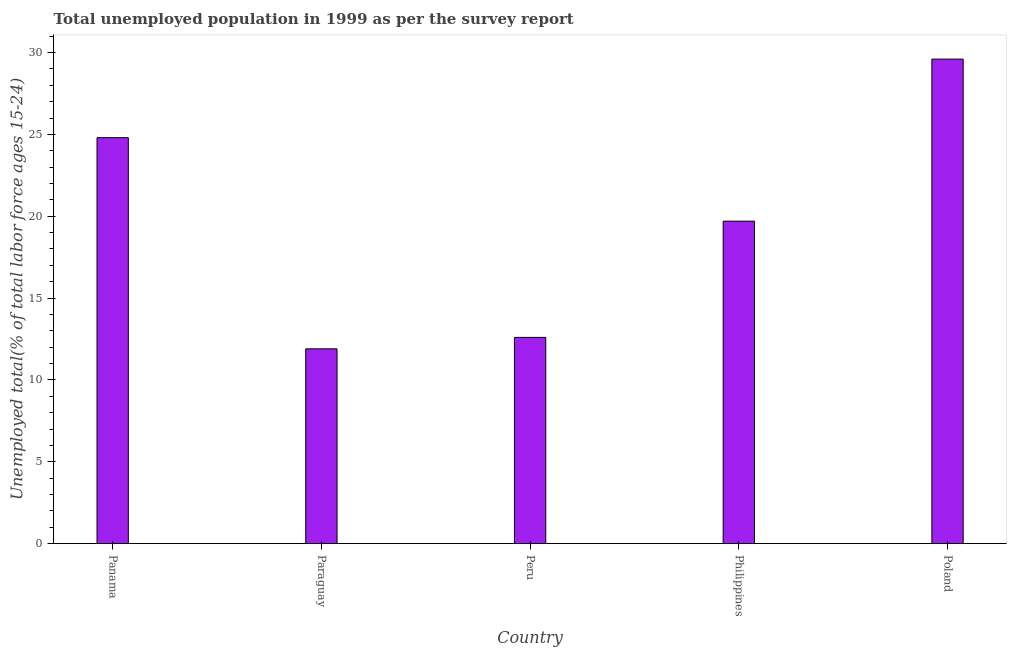What is the title of the graph?
Your answer should be compact. Total unemployed population in 1999 as per the survey report. What is the label or title of the Y-axis?
Your answer should be compact. Unemployed total(% of total labor force ages 15-24). What is the unemployed youth in Panama?
Your response must be concise. 24.8. Across all countries, what is the maximum unemployed youth?
Provide a short and direct response. 29.6. Across all countries, what is the minimum unemployed youth?
Your answer should be very brief. 11.9. In which country was the unemployed youth maximum?
Ensure brevity in your answer.  Poland. In which country was the unemployed youth minimum?
Your answer should be compact. Paraguay. What is the sum of the unemployed youth?
Ensure brevity in your answer.  98.6. What is the average unemployed youth per country?
Offer a terse response. 19.72. What is the median unemployed youth?
Provide a short and direct response. 19.7. What is the ratio of the unemployed youth in Peru to that in Poland?
Offer a terse response. 0.43. What is the difference between the highest and the second highest unemployed youth?
Offer a very short reply. 4.8. What is the difference between the highest and the lowest unemployed youth?
Your answer should be compact. 17.7. In how many countries, is the unemployed youth greater than the average unemployed youth taken over all countries?
Keep it short and to the point. 2. How many bars are there?
Keep it short and to the point. 5. Are all the bars in the graph horizontal?
Your answer should be compact. No. How many countries are there in the graph?
Offer a very short reply. 5. Are the values on the major ticks of Y-axis written in scientific E-notation?
Your response must be concise. No. What is the Unemployed total(% of total labor force ages 15-24) in Panama?
Give a very brief answer. 24.8. What is the Unemployed total(% of total labor force ages 15-24) in Paraguay?
Provide a succinct answer. 11.9. What is the Unemployed total(% of total labor force ages 15-24) of Peru?
Ensure brevity in your answer.  12.6. What is the Unemployed total(% of total labor force ages 15-24) in Philippines?
Your answer should be very brief. 19.7. What is the Unemployed total(% of total labor force ages 15-24) in Poland?
Ensure brevity in your answer.  29.6. What is the difference between the Unemployed total(% of total labor force ages 15-24) in Panama and Paraguay?
Your answer should be compact. 12.9. What is the difference between the Unemployed total(% of total labor force ages 15-24) in Panama and Peru?
Offer a very short reply. 12.2. What is the difference between the Unemployed total(% of total labor force ages 15-24) in Panama and Philippines?
Your response must be concise. 5.1. What is the difference between the Unemployed total(% of total labor force ages 15-24) in Paraguay and Poland?
Offer a terse response. -17.7. What is the difference between the Unemployed total(% of total labor force ages 15-24) in Peru and Poland?
Provide a short and direct response. -17. What is the ratio of the Unemployed total(% of total labor force ages 15-24) in Panama to that in Paraguay?
Provide a short and direct response. 2.08. What is the ratio of the Unemployed total(% of total labor force ages 15-24) in Panama to that in Peru?
Ensure brevity in your answer.  1.97. What is the ratio of the Unemployed total(% of total labor force ages 15-24) in Panama to that in Philippines?
Make the answer very short. 1.26. What is the ratio of the Unemployed total(% of total labor force ages 15-24) in Panama to that in Poland?
Your answer should be very brief. 0.84. What is the ratio of the Unemployed total(% of total labor force ages 15-24) in Paraguay to that in Peru?
Ensure brevity in your answer.  0.94. What is the ratio of the Unemployed total(% of total labor force ages 15-24) in Paraguay to that in Philippines?
Provide a succinct answer. 0.6. What is the ratio of the Unemployed total(% of total labor force ages 15-24) in Paraguay to that in Poland?
Offer a very short reply. 0.4. What is the ratio of the Unemployed total(% of total labor force ages 15-24) in Peru to that in Philippines?
Give a very brief answer. 0.64. What is the ratio of the Unemployed total(% of total labor force ages 15-24) in Peru to that in Poland?
Make the answer very short. 0.43. What is the ratio of the Unemployed total(% of total labor force ages 15-24) in Philippines to that in Poland?
Ensure brevity in your answer.  0.67. 